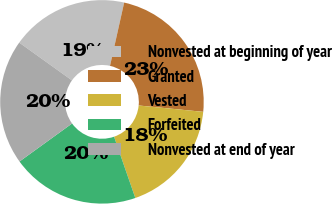Convert chart. <chart><loc_0><loc_0><loc_500><loc_500><pie_chart><fcel>Nonvested at beginning of year<fcel>Granted<fcel>Vested<fcel>Forfeited<fcel>Nonvested at end of year<nl><fcel>18.61%<fcel>23.06%<fcel>18.12%<fcel>20.35%<fcel>19.86%<nl></chart> 